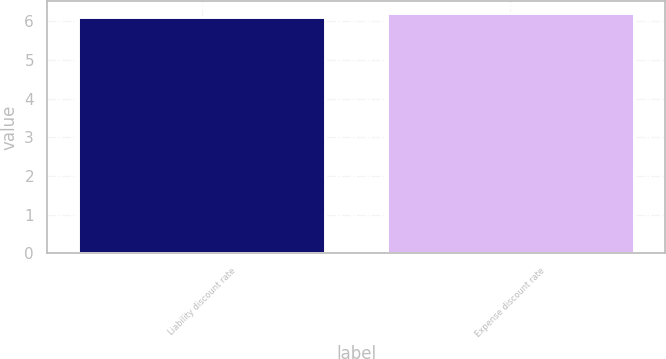Convert chart. <chart><loc_0><loc_0><loc_500><loc_500><bar_chart><fcel>Liability discount rate<fcel>Expense discount rate<nl><fcel>6.1<fcel>6.2<nl></chart> 